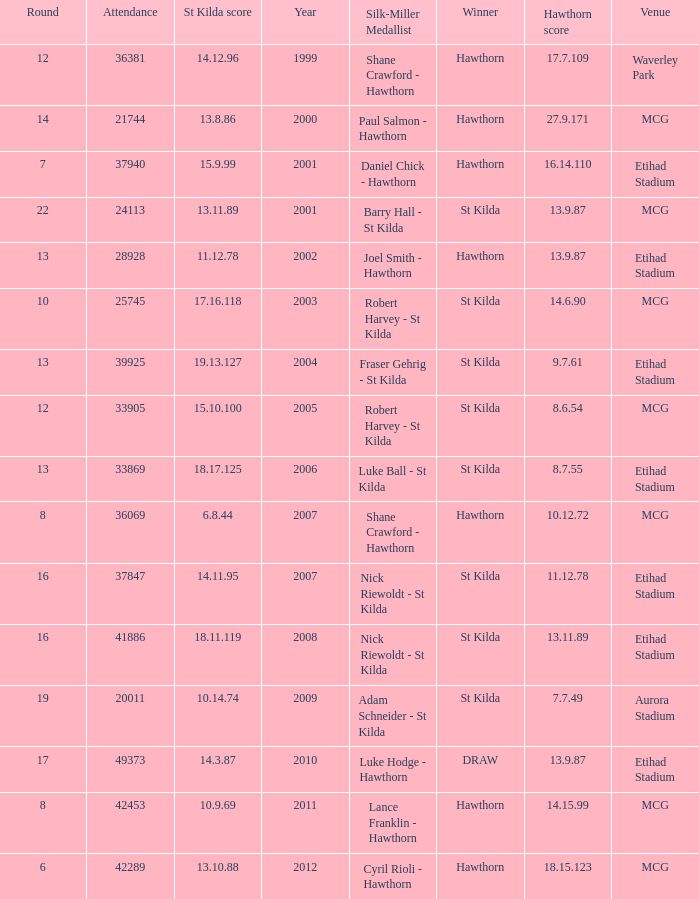Write the full table. {'header': ['Round', 'Attendance', 'St Kilda score', 'Year', 'Silk-Miller Medallist', 'Winner', 'Hawthorn score', 'Venue'], 'rows': [['12', '36381', '14.12.96', '1999', 'Shane Crawford - Hawthorn', 'Hawthorn', '17.7.109', 'Waverley Park'], ['14', '21744', '13.8.86', '2000', 'Paul Salmon - Hawthorn', 'Hawthorn', '27.9.171', 'MCG'], ['7', '37940', '15.9.99', '2001', 'Daniel Chick - Hawthorn', 'Hawthorn', '16.14.110', 'Etihad Stadium'], ['22', '24113', '13.11.89', '2001', 'Barry Hall - St Kilda', 'St Kilda', '13.9.87', 'MCG'], ['13', '28928', '11.12.78', '2002', 'Joel Smith - Hawthorn', 'Hawthorn', '13.9.87', 'Etihad Stadium'], ['10', '25745', '17.16.118', '2003', 'Robert Harvey - St Kilda', 'St Kilda', '14.6.90', 'MCG'], ['13', '39925', '19.13.127', '2004', 'Fraser Gehrig - St Kilda', 'St Kilda', '9.7.61', 'Etihad Stadium'], ['12', '33905', '15.10.100', '2005', 'Robert Harvey - St Kilda', 'St Kilda', '8.6.54', 'MCG'], ['13', '33869', '18.17.125', '2006', 'Luke Ball - St Kilda', 'St Kilda', '8.7.55', 'Etihad Stadium'], ['8', '36069', '6.8.44', '2007', 'Shane Crawford - Hawthorn', 'Hawthorn', '10.12.72', 'MCG'], ['16', '37847', '14.11.95', '2007', 'Nick Riewoldt - St Kilda', 'St Kilda', '11.12.78', 'Etihad Stadium'], ['16', '41886', '18.11.119', '2008', 'Nick Riewoldt - St Kilda', 'St Kilda', '13.11.89', 'Etihad Stadium'], ['19', '20011', '10.14.74', '2009', 'Adam Schneider - St Kilda', 'St Kilda', '7.7.49', 'Aurora Stadium'], ['17', '49373', '14.3.87', '2010', 'Luke Hodge - Hawthorn', 'DRAW', '13.9.87', 'Etihad Stadium'], ['8', '42453', '10.9.69', '2011', 'Lance Franklin - Hawthorn', 'Hawthorn', '14.15.99', 'MCG'], ['6', '42289', '13.10.88', '2012', 'Cyril Rioli - Hawthorn', 'Hawthorn', '18.15.123', 'MCG']]} What is the hawthorn score at the year 2000? 279171.0. 